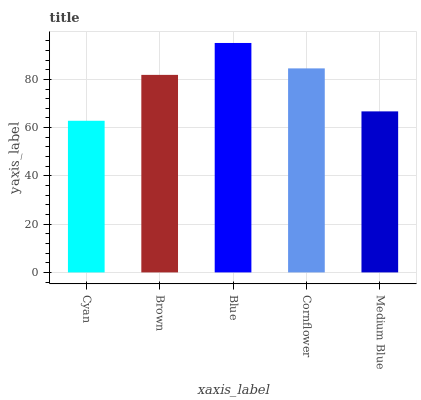Is Cyan the minimum?
Answer yes or no. Yes. Is Blue the maximum?
Answer yes or no. Yes. Is Brown the minimum?
Answer yes or no. No. Is Brown the maximum?
Answer yes or no. No. Is Brown greater than Cyan?
Answer yes or no. Yes. Is Cyan less than Brown?
Answer yes or no. Yes. Is Cyan greater than Brown?
Answer yes or no. No. Is Brown less than Cyan?
Answer yes or no. No. Is Brown the high median?
Answer yes or no. Yes. Is Brown the low median?
Answer yes or no. Yes. Is Medium Blue the high median?
Answer yes or no. No. Is Blue the low median?
Answer yes or no. No. 